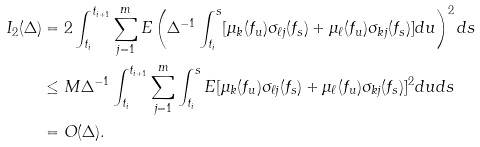<formula> <loc_0><loc_0><loc_500><loc_500>I _ { 2 } ( \Delta ) & = 2 \int _ { t _ { i } } ^ { t _ { i + 1 } } \sum _ { j = 1 } ^ { m } E \left ( \Delta ^ { - 1 } \int _ { t _ { i } } ^ { s } [ \mu _ { k } ( f _ { u } ) \sigma _ { \ell j } ( f _ { s } ) + \mu _ { \ell } ( f _ { u } ) \sigma _ { k j } ( f _ { s } ) ] d u \right ) ^ { 2 } d s \\ & \leq M \Delta ^ { - 1 } \int _ { t _ { i } } ^ { t _ { i + 1 } } \sum _ { j = 1 } ^ { m } \int _ { t _ { i } } ^ { s } E [ \mu _ { k } ( f _ { u } ) \sigma _ { \ell j } ( f _ { s } ) + \mu _ { \ell } ( f _ { u } ) \sigma _ { k j } ( f _ { s } ) ] ^ { 2 } d u d s \\ & = O ( \Delta ) .</formula> 